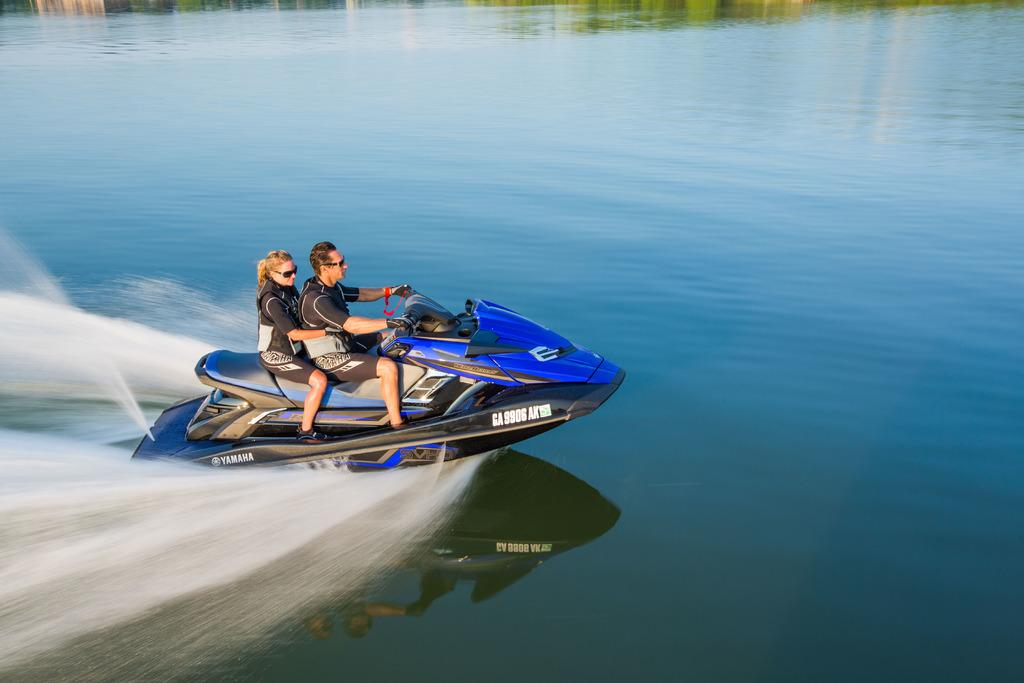How many people are in the image? There are two persons in the image. What are the two persons doing in the image? The two persons are riding a speedboat. Where is the speedboat located in the image? The speedboat is on a river. How many other boats can be seen in the image? There is no mention of other boats in the image; only a speedboat is present. What type of camera is being used to take the picture? There is no camera visible in the image, as the focus is on the two persons riding the speedboat. 